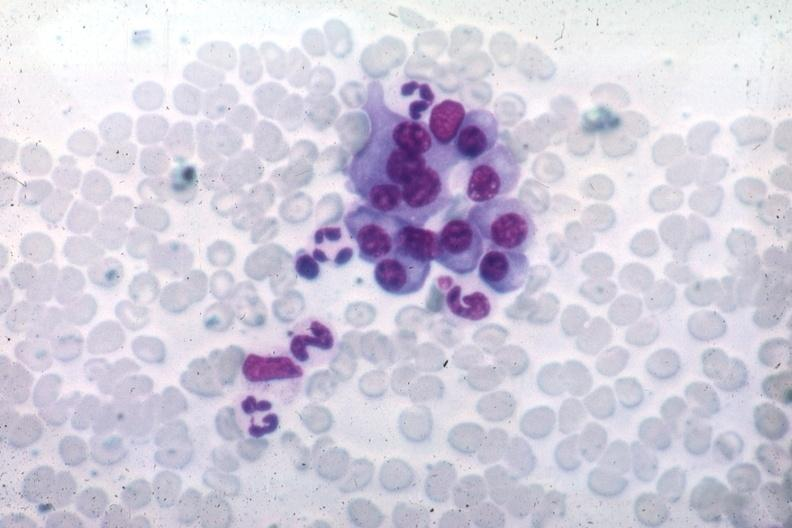s this image shows wrights typical differentiated plasma cells source unknown?
Answer the question using a single word or phrase. Yes 